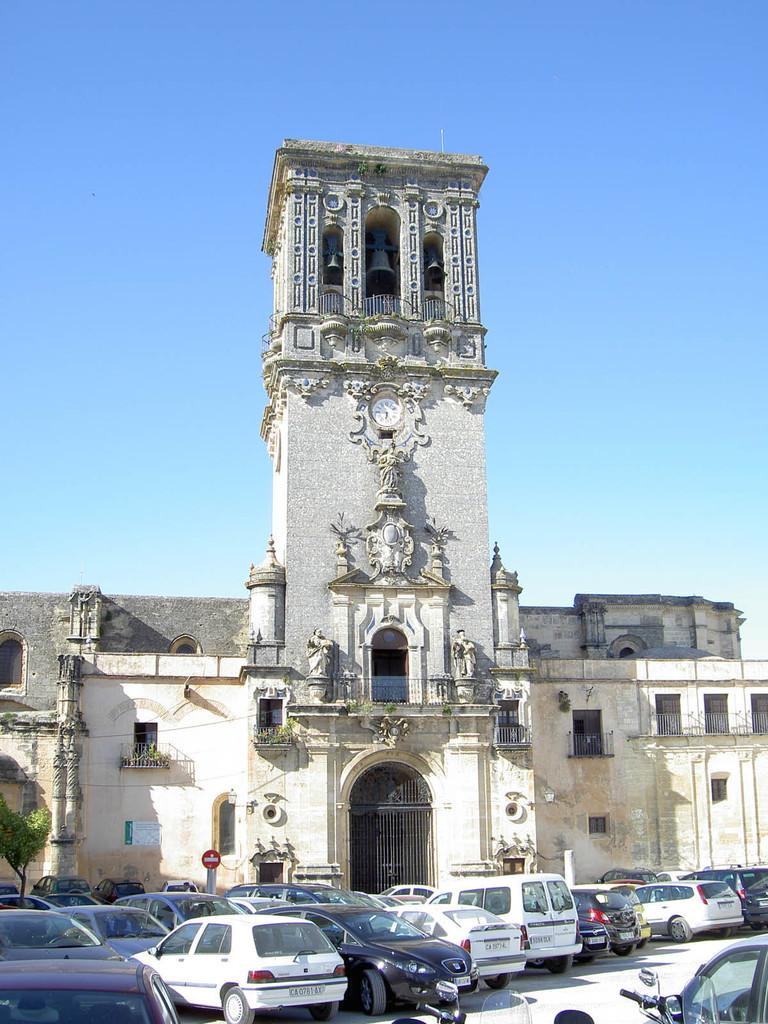What types of objects are on the ground in the image? There are vehicles on the ground in the image. What is the structure with windows in the image? There is a building with windows in the image. What type of natural elements can be seen in the image? There are plants and a tree in the image. What type of decorative objects are in the image? There are statues in the image. What type of timekeeping device is in the image? There is a clock in the image. What type of musical instruments are in the image? There are bells in the image. What type of signage is in the image? There is a signboard in the image. What type of promotional material is in the image? There is a poster in the image. What type of cooking equipment is in the image? There are grills in the image. What can be seen in the background of the image? The sky is visible in the background of the image. What type of dress is being sold in the image? There is no dress being sold in the image; the focus is on vehicles, a building, plants, a tree, statues, a clock, bells, a signboard, a poster, grills, and the sky. How can payment be made for the items in the image? There is no indication of a payment method or items for sale in the image. 